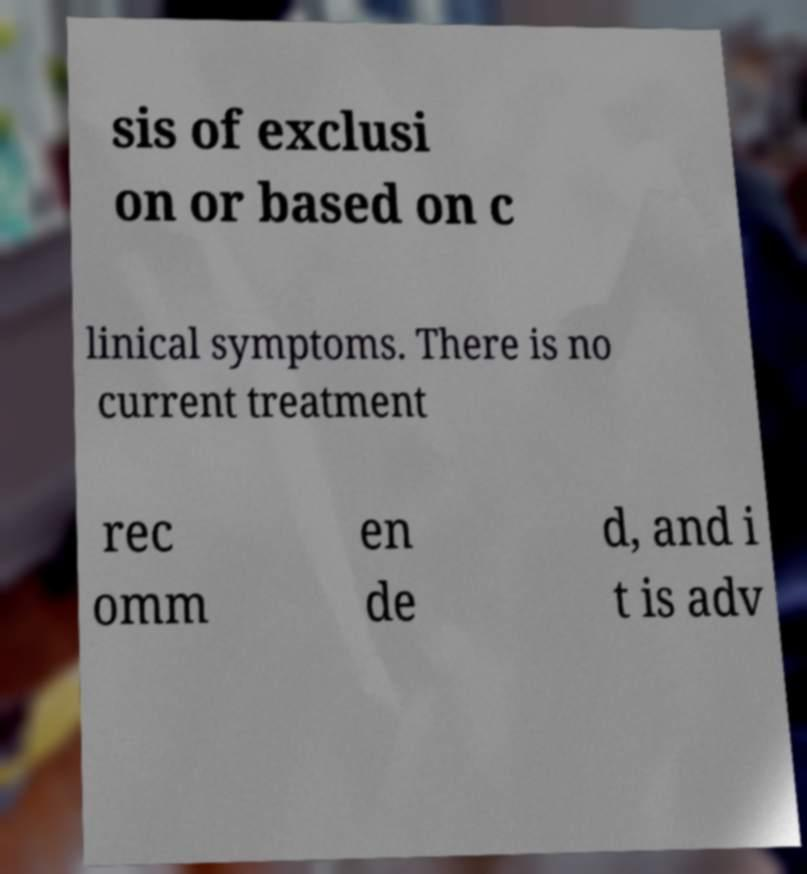Please identify and transcribe the text found in this image. sis of exclusi on or based on c linical symptoms. There is no current treatment rec omm en de d, and i t is adv 